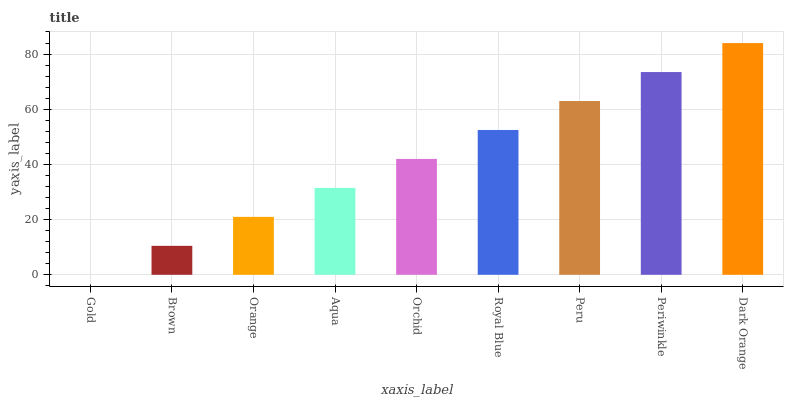Is Gold the minimum?
Answer yes or no. Yes. Is Dark Orange the maximum?
Answer yes or no. Yes. Is Brown the minimum?
Answer yes or no. No. Is Brown the maximum?
Answer yes or no. No. Is Brown greater than Gold?
Answer yes or no. Yes. Is Gold less than Brown?
Answer yes or no. Yes. Is Gold greater than Brown?
Answer yes or no. No. Is Brown less than Gold?
Answer yes or no. No. Is Orchid the high median?
Answer yes or no. Yes. Is Orchid the low median?
Answer yes or no. Yes. Is Brown the high median?
Answer yes or no. No. Is Brown the low median?
Answer yes or no. No. 